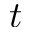<formula> <loc_0><loc_0><loc_500><loc_500>t</formula> 